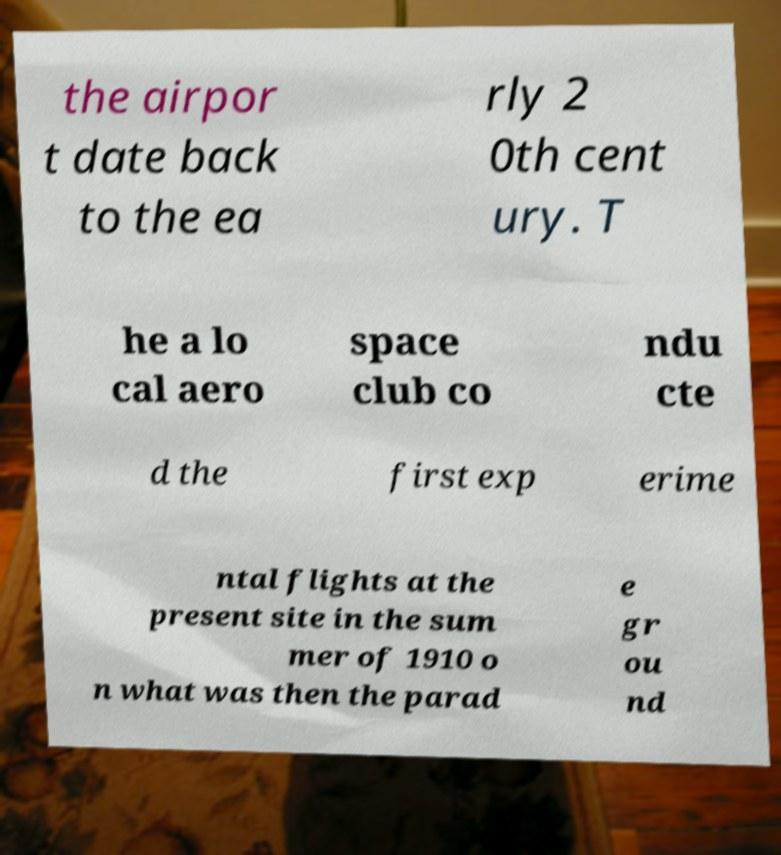Please read and relay the text visible in this image. What does it say? the airpor t date back to the ea rly 2 0th cent ury. T he a lo cal aero space club co ndu cte d the first exp erime ntal flights at the present site in the sum mer of 1910 o n what was then the parad e gr ou nd 